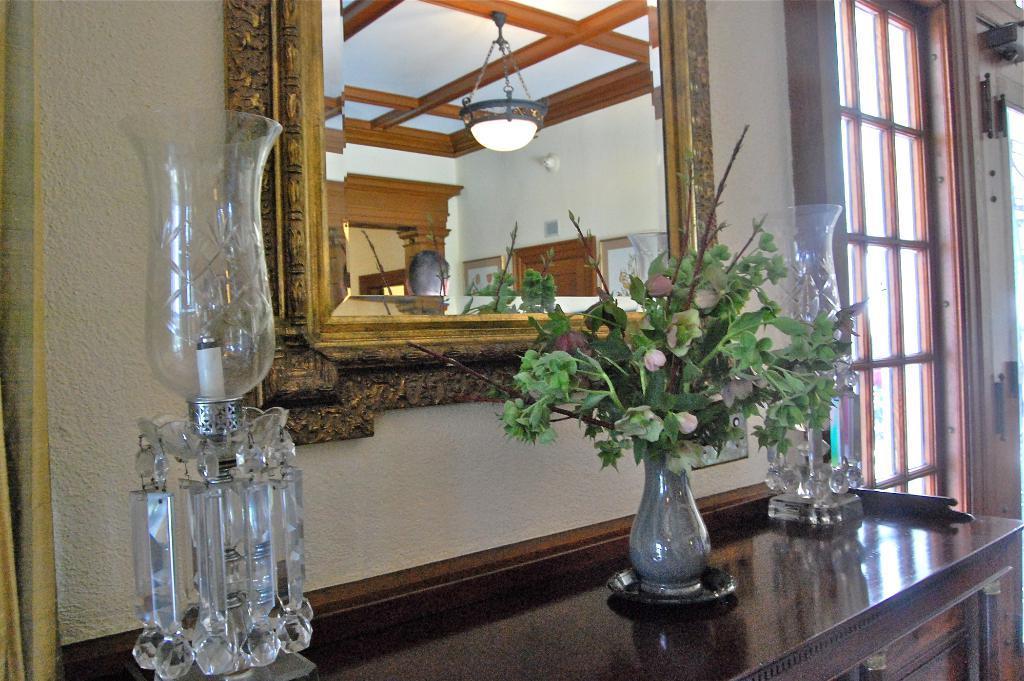Can you describe this image briefly? In the middle there is a mirror , in front of the mirror there is a flower vase and candle light. On the right there is a door and glass. The picture is clicked inside the house. 